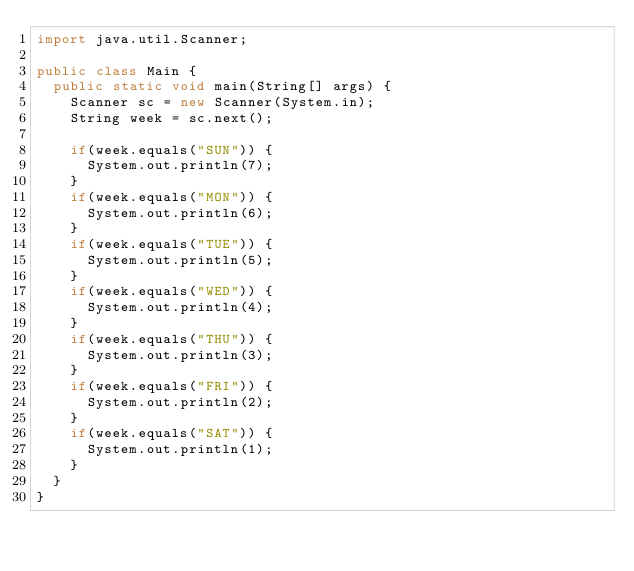<code> <loc_0><loc_0><loc_500><loc_500><_Java_>import java.util.Scanner;

public class Main {
	public static void main(String[] args) {
		Scanner sc = new Scanner(System.in);
		String week = sc.next();

		if(week.equals("SUN")) {
			System.out.println(7);
		}
		if(week.equals("MON")) {
			System.out.println(6);
		}
		if(week.equals("TUE")) {
			System.out.println(5);
		}
		if(week.equals("WED")) {
			System.out.println(4);
		}
		if(week.equals("THU")) {
			System.out.println(3);
		}
		if(week.equals("FRI")) {
			System.out.println(2);
		}
		if(week.equals("SAT")) {
			System.out.println(1);
		}
	}
}</code> 